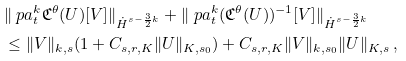<formula> <loc_0><loc_0><loc_500><loc_500>& \| \ p a _ { t } ^ { k } \mathfrak { C } ^ { \theta } ( U ) [ V ] \| _ { \dot { H } ^ { s - \frac { 3 } { 2 } k } } + \| \ p a _ { t } ^ { k } ( \mathfrak { C } ^ { \theta } ( U ) ) ^ { - 1 } [ V ] \| _ { \dot { H } ^ { s - \frac { 3 } { 2 } k } } \\ & \leq \| V \| _ { k , s } ( 1 + C _ { s , r , K } \| U \| _ { K , s _ { 0 } } ) + C _ { s , r , K } \| V \| _ { k , s _ { 0 } } \| U \| _ { K , s } \, ,</formula> 